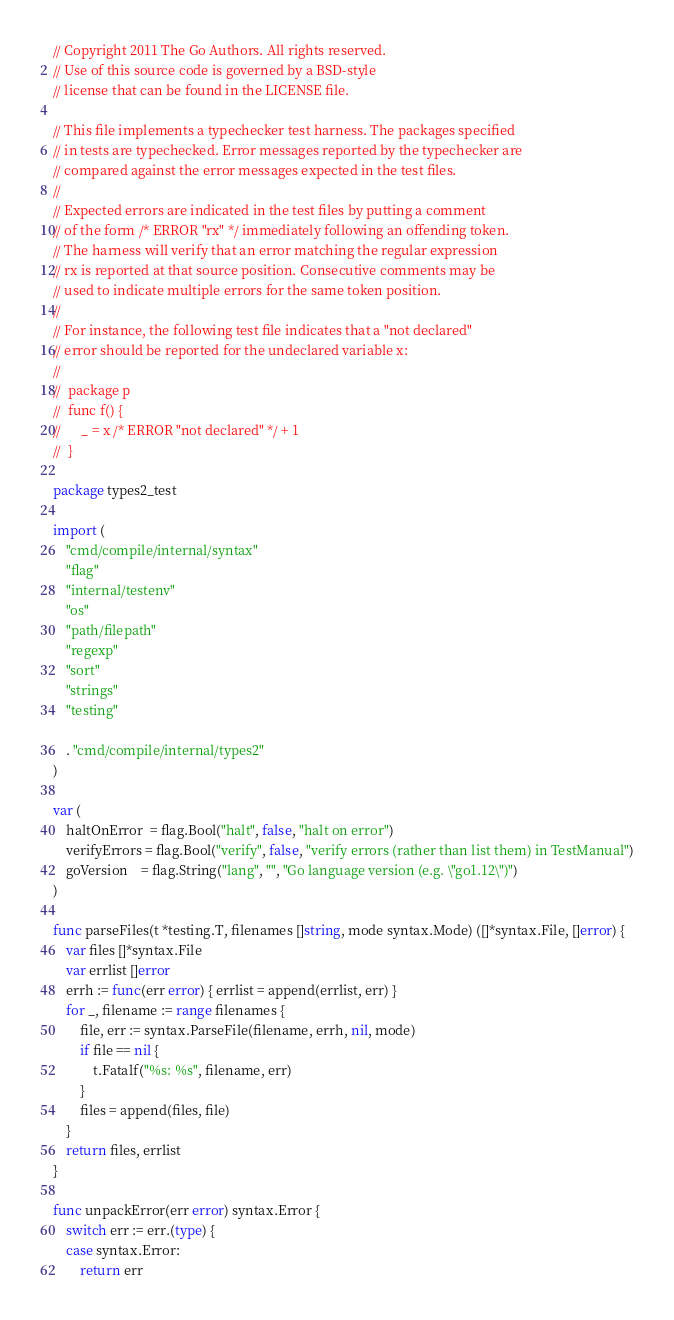<code> <loc_0><loc_0><loc_500><loc_500><_Go_>// Copyright 2011 The Go Authors. All rights reserved.
// Use of this source code is governed by a BSD-style
// license that can be found in the LICENSE file.

// This file implements a typechecker test harness. The packages specified
// in tests are typechecked. Error messages reported by the typechecker are
// compared against the error messages expected in the test files.
//
// Expected errors are indicated in the test files by putting a comment
// of the form /* ERROR "rx" */ immediately following an offending token.
// The harness will verify that an error matching the regular expression
// rx is reported at that source position. Consecutive comments may be
// used to indicate multiple errors for the same token position.
//
// For instance, the following test file indicates that a "not declared"
// error should be reported for the undeclared variable x:
//
//	package p
//	func f() {
//		_ = x /* ERROR "not declared" */ + 1
//	}

package types2_test

import (
	"cmd/compile/internal/syntax"
	"flag"
	"internal/testenv"
	"os"
	"path/filepath"
	"regexp"
	"sort"
	"strings"
	"testing"

	. "cmd/compile/internal/types2"
)

var (
	haltOnError  = flag.Bool("halt", false, "halt on error")
	verifyErrors = flag.Bool("verify", false, "verify errors (rather than list them) in TestManual")
	goVersion    = flag.String("lang", "", "Go language version (e.g. \"go1.12\")")
)

func parseFiles(t *testing.T, filenames []string, mode syntax.Mode) ([]*syntax.File, []error) {
	var files []*syntax.File
	var errlist []error
	errh := func(err error) { errlist = append(errlist, err) }
	for _, filename := range filenames {
		file, err := syntax.ParseFile(filename, errh, nil, mode)
		if file == nil {
			t.Fatalf("%s: %s", filename, err)
		}
		files = append(files, file)
	}
	return files, errlist
}

func unpackError(err error) syntax.Error {
	switch err := err.(type) {
	case syntax.Error:
		return err</code> 